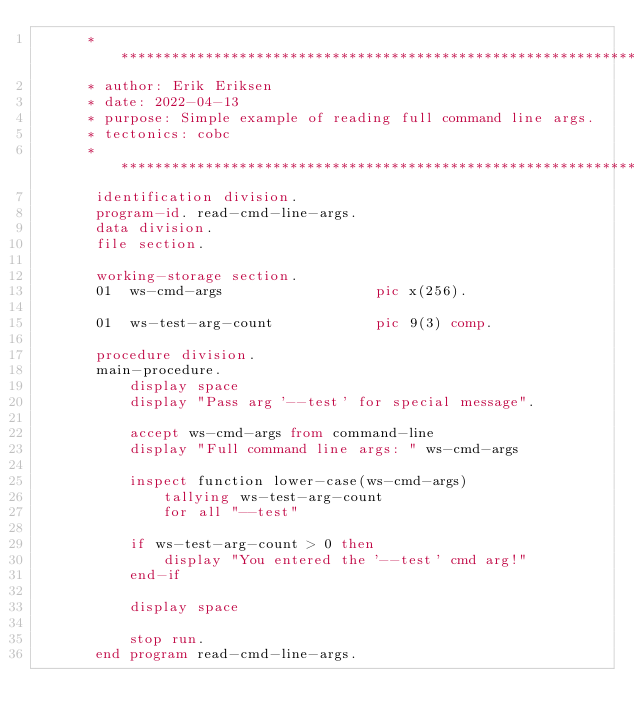Convert code to text. <code><loc_0><loc_0><loc_500><loc_500><_COBOL_>      ******************************************************************
      * author: Erik Eriksen
      * date: 2022-04-13
      * purpose: Simple example of reading full command line args.
      * tectonics: cobc
      ******************************************************************
       identification division.
       program-id. read-cmd-line-args.
       data division.
       file section.

       working-storage section.
       01  ws-cmd-args                  pic x(256).

       01  ws-test-arg-count            pic 9(3) comp.

       procedure division.
       main-procedure.
           display space
           display "Pass arg '--test' for special message".

           accept ws-cmd-args from command-line
           display "Full command line args: " ws-cmd-args

           inspect function lower-case(ws-cmd-args)
               tallying ws-test-arg-count
               for all "--test"

           if ws-test-arg-count > 0 then
               display "You entered the '--test' cmd arg!"
           end-if

           display space

           stop run.
       end program read-cmd-line-args.
</code> 